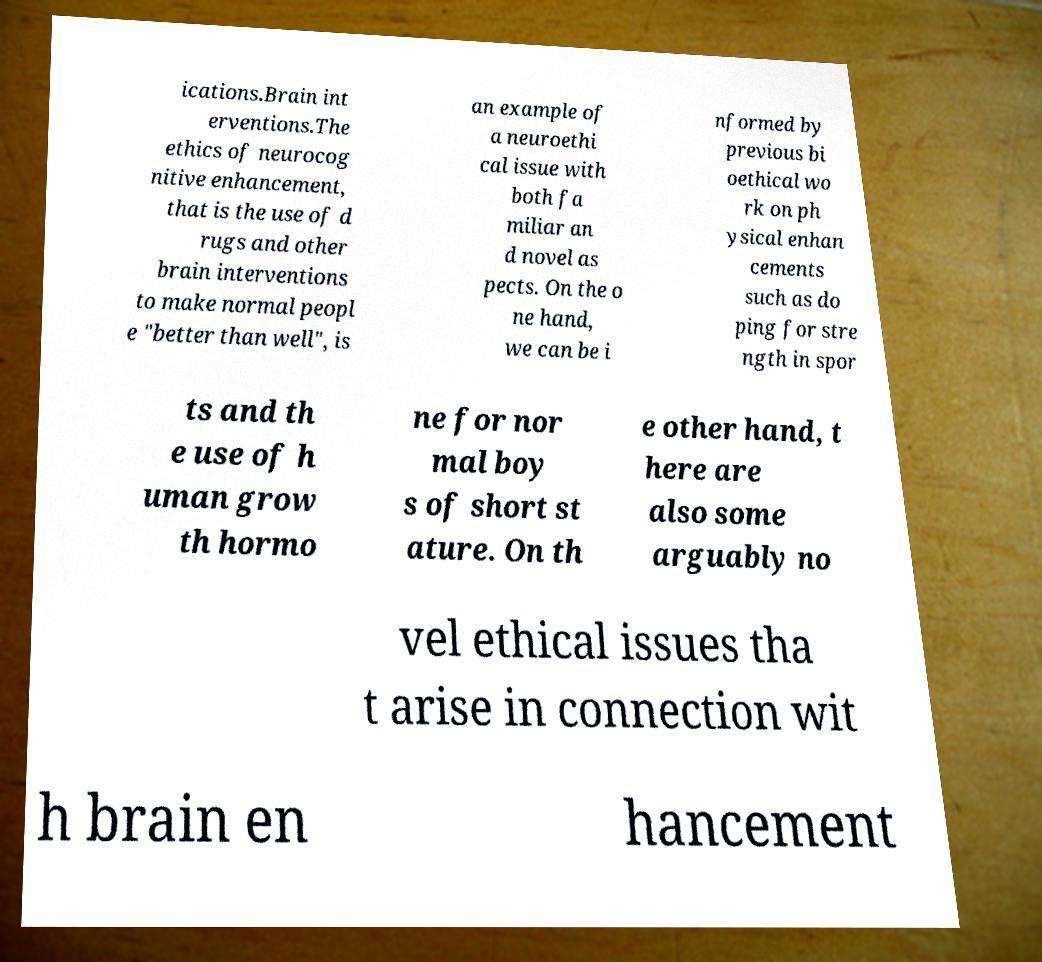I need the written content from this picture converted into text. Can you do that? ications.Brain int erventions.The ethics of neurocog nitive enhancement, that is the use of d rugs and other brain interventions to make normal peopl e "better than well", is an example of a neuroethi cal issue with both fa miliar an d novel as pects. On the o ne hand, we can be i nformed by previous bi oethical wo rk on ph ysical enhan cements such as do ping for stre ngth in spor ts and th e use of h uman grow th hormo ne for nor mal boy s of short st ature. On th e other hand, t here are also some arguably no vel ethical issues tha t arise in connection wit h brain en hancement 